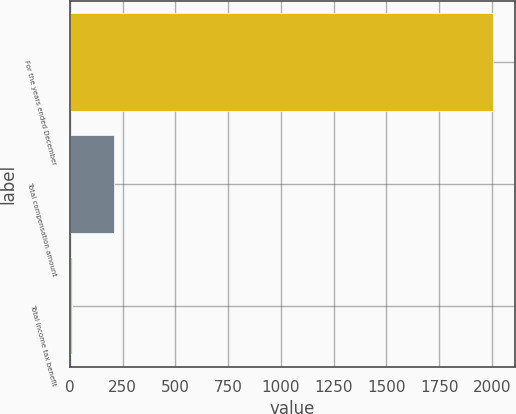Convert chart. <chart><loc_0><loc_0><loc_500><loc_500><bar_chart><fcel>For the years ended December<fcel>Total compensation amount<fcel>Total income tax benefit<nl><fcel>2007<fcel>209.61<fcel>9.9<nl></chart> 